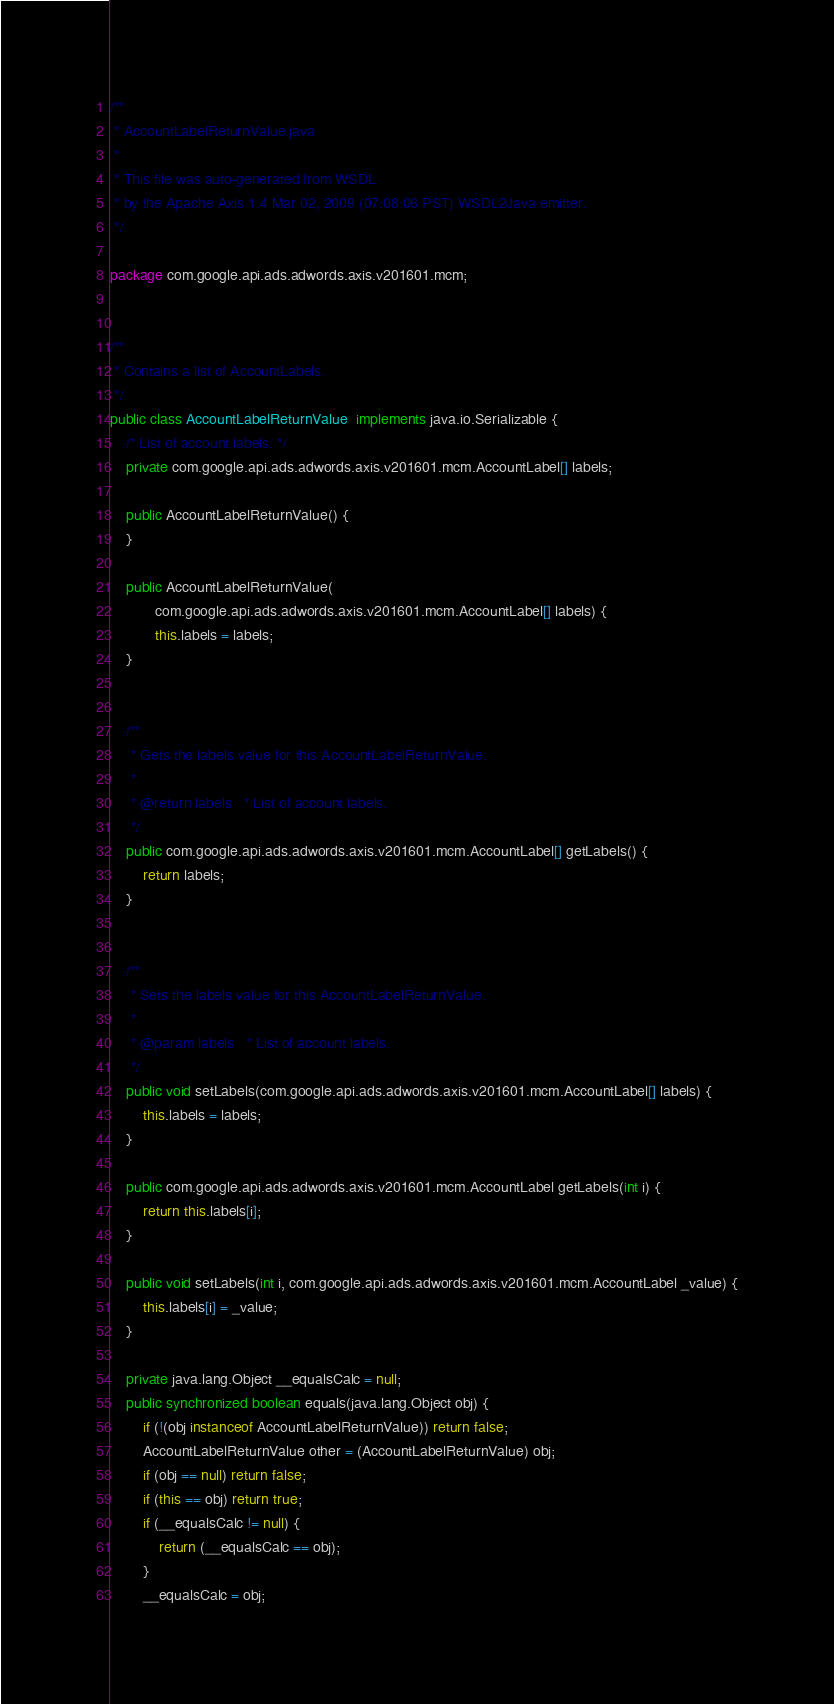<code> <loc_0><loc_0><loc_500><loc_500><_Java_>/**
 * AccountLabelReturnValue.java
 *
 * This file was auto-generated from WSDL
 * by the Apache Axis 1.4 Mar 02, 2009 (07:08:06 PST) WSDL2Java emitter.
 */

package com.google.api.ads.adwords.axis.v201601.mcm;


/**
 * Contains a list of AccountLabels.
 */
public class AccountLabelReturnValue  implements java.io.Serializable {
    /* List of account labels. */
    private com.google.api.ads.adwords.axis.v201601.mcm.AccountLabel[] labels;

    public AccountLabelReturnValue() {
    }

    public AccountLabelReturnValue(
           com.google.api.ads.adwords.axis.v201601.mcm.AccountLabel[] labels) {
           this.labels = labels;
    }


    /**
     * Gets the labels value for this AccountLabelReturnValue.
     * 
     * @return labels   * List of account labels.
     */
    public com.google.api.ads.adwords.axis.v201601.mcm.AccountLabel[] getLabels() {
        return labels;
    }


    /**
     * Sets the labels value for this AccountLabelReturnValue.
     * 
     * @param labels   * List of account labels.
     */
    public void setLabels(com.google.api.ads.adwords.axis.v201601.mcm.AccountLabel[] labels) {
        this.labels = labels;
    }

    public com.google.api.ads.adwords.axis.v201601.mcm.AccountLabel getLabels(int i) {
        return this.labels[i];
    }

    public void setLabels(int i, com.google.api.ads.adwords.axis.v201601.mcm.AccountLabel _value) {
        this.labels[i] = _value;
    }

    private java.lang.Object __equalsCalc = null;
    public synchronized boolean equals(java.lang.Object obj) {
        if (!(obj instanceof AccountLabelReturnValue)) return false;
        AccountLabelReturnValue other = (AccountLabelReturnValue) obj;
        if (obj == null) return false;
        if (this == obj) return true;
        if (__equalsCalc != null) {
            return (__equalsCalc == obj);
        }
        __equalsCalc = obj;</code> 